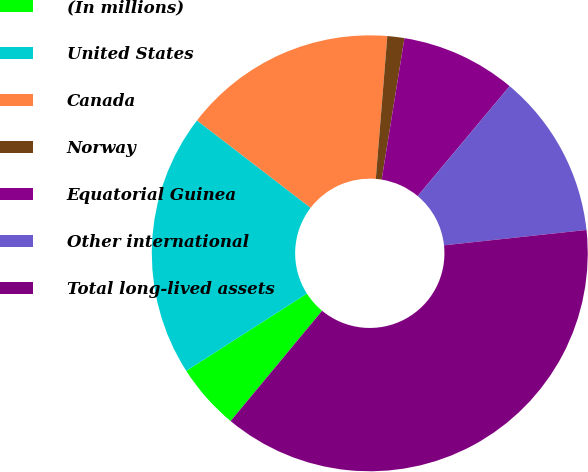Convert chart. <chart><loc_0><loc_0><loc_500><loc_500><pie_chart><fcel>(In millions)<fcel>United States<fcel>Canada<fcel>Norway<fcel>Equatorial Guinea<fcel>Other international<fcel>Total long-lived assets<nl><fcel>4.91%<fcel>19.5%<fcel>15.85%<fcel>1.26%<fcel>8.55%<fcel>12.2%<fcel>37.73%<nl></chart> 